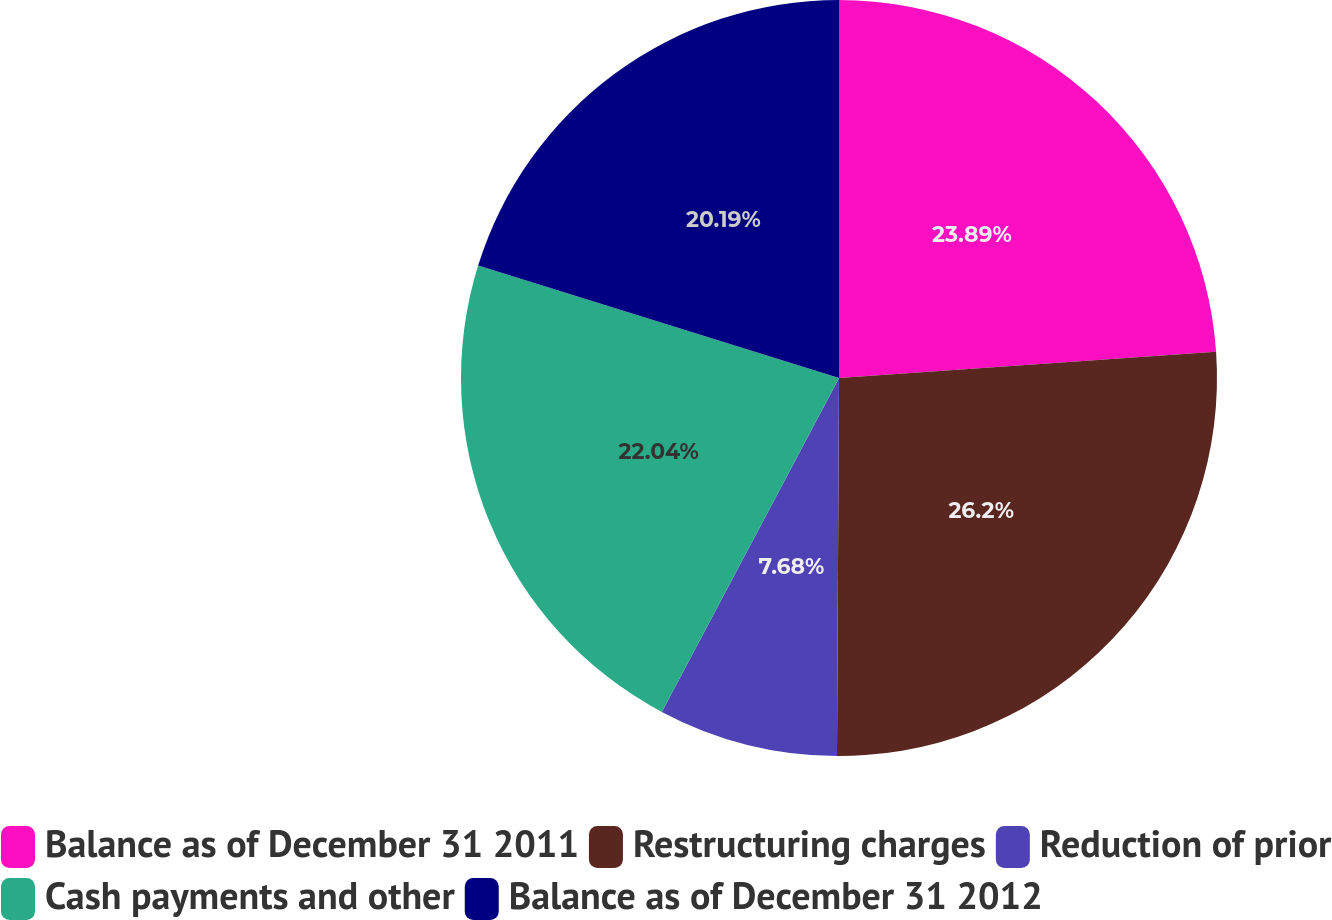Convert chart to OTSL. <chart><loc_0><loc_0><loc_500><loc_500><pie_chart><fcel>Balance as of December 31 2011<fcel>Restructuring charges<fcel>Reduction of prior<fcel>Cash payments and other<fcel>Balance as of December 31 2012<nl><fcel>23.89%<fcel>26.19%<fcel>7.68%<fcel>22.04%<fcel>20.19%<nl></chart> 